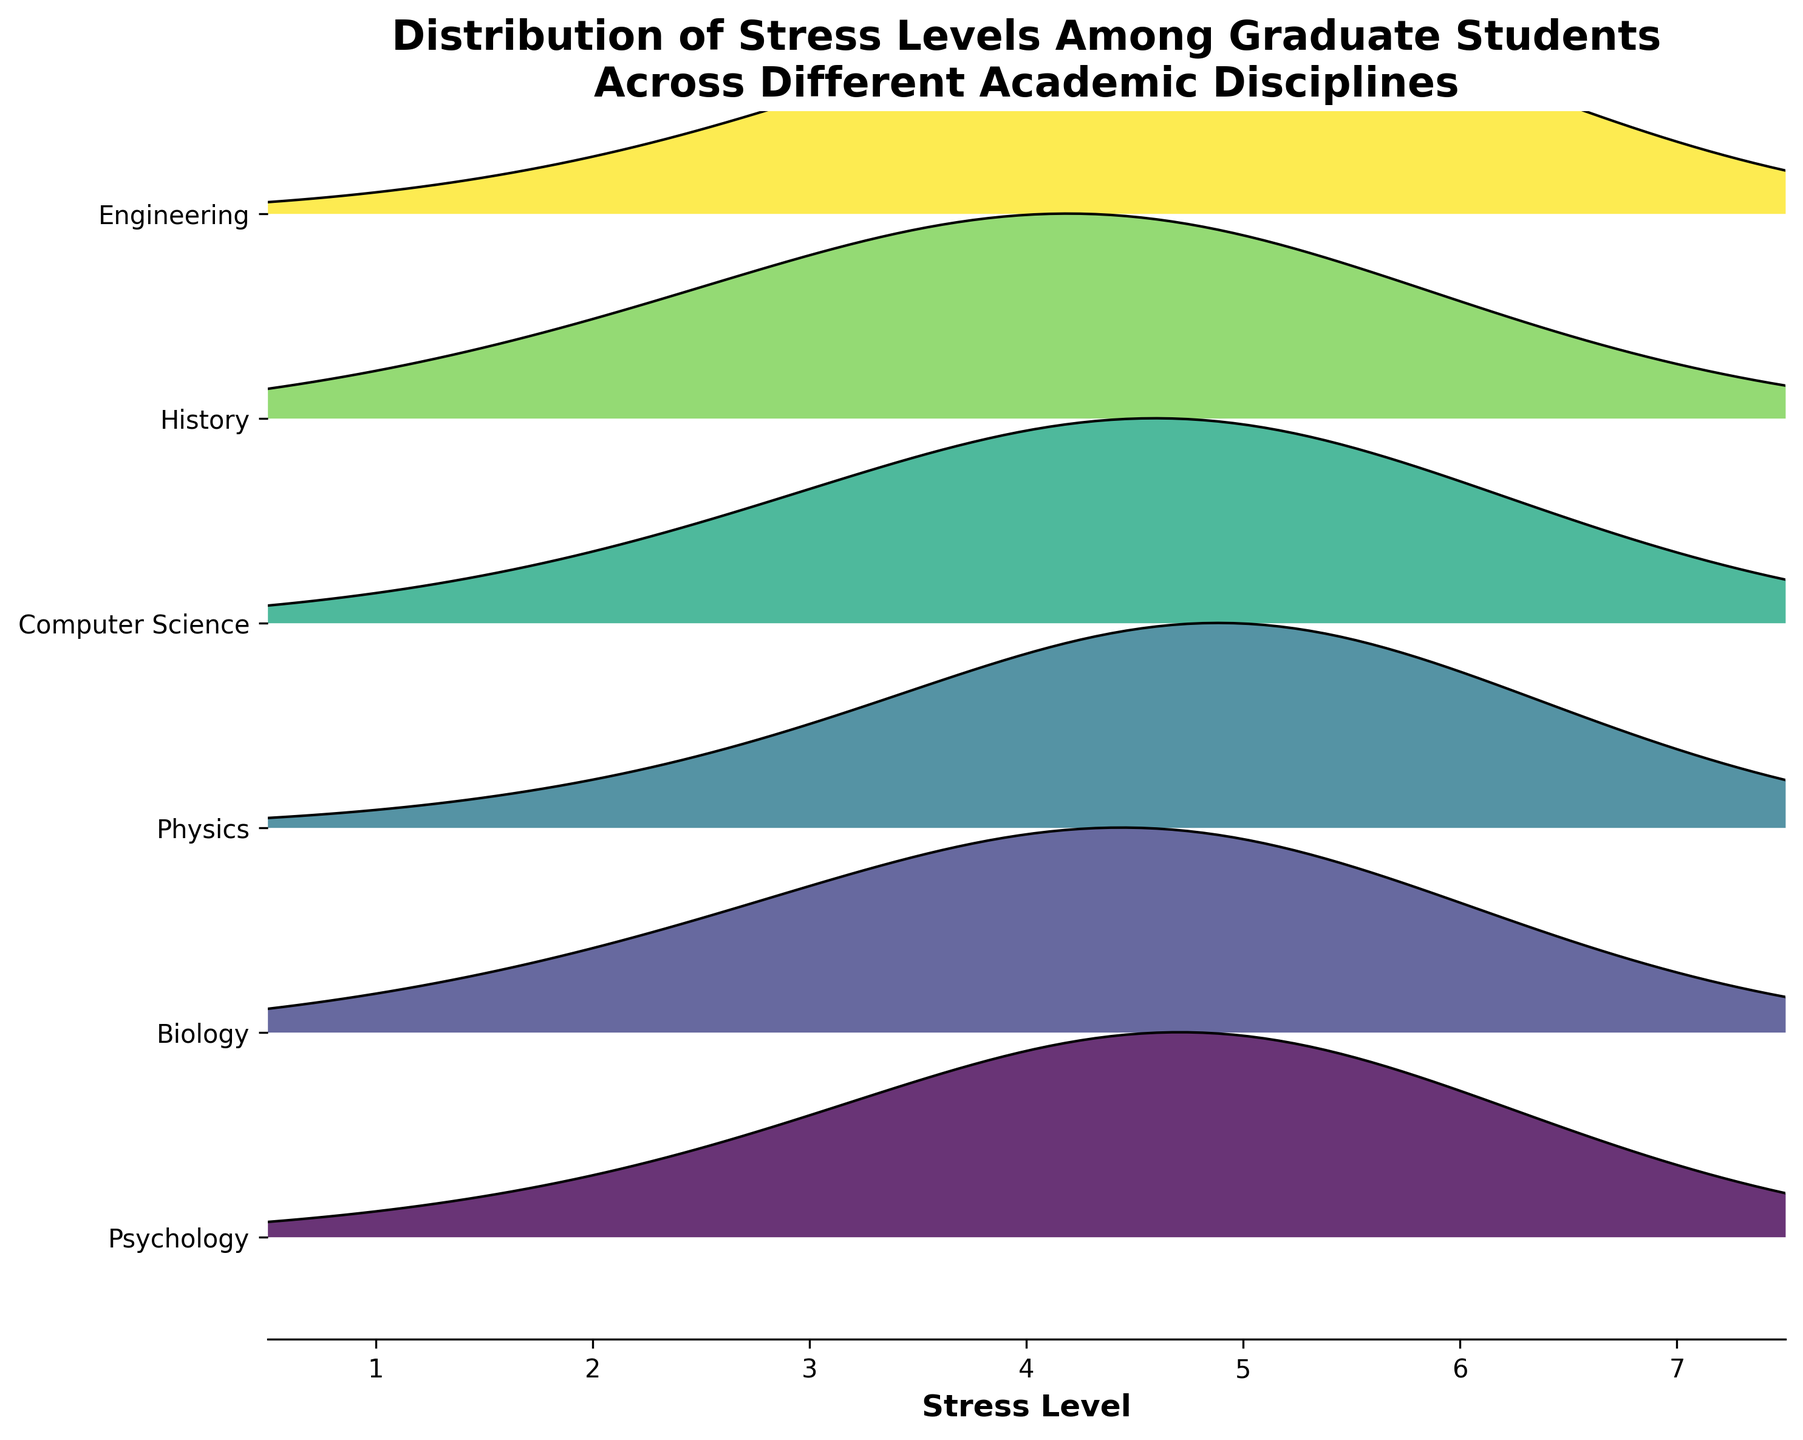What is the title of the figure? The title is usually found at the top of the figure, generally in a larger, bold font for emphasis. It summarizes the content of the plot.
Answer: Distribution of Stress Levels Among Graduate Students Across Different Academic Disciplines Which academic discipline shows the highest peak in stress levels? By examining the height of the peaks in the ridgeline plot, we can determine which discipline has the most pronounced density at any given stress level. Look for the discipline where the peak is closest to the top of the plot.
Answer: Physics Between Psychology and Biology, which discipline has a higher density for stress level 4? To find this, compare the height of the density curve at stress level 4 for both Psychology and Biology. The discipline with the higher peak at this point has the higher density.
Answer: Biology What is the range of stress levels shown in the plot? The x-axis of the plot provides the range of stress levels. Check the minimum and maximum values labeled on the x-axis.
Answer: 1 to 7 Which discipline has the most even distribution of stress levels, meaning no significant peaks? An even distribution would mean the density values change gently and gradually rather than having sharp peaks. Look for the plot line that is relatively flat without pronounced peaks.
Answer: History Are any disciplines showing a bimodal distribution of stress levels? A bimodal distribution would have two distinct peaks in the density curve. Scan the plot for any discipline with two separate high points in its density curve.
Answer: No Do any disciplines have their highest density at a stress level below 4? Determine whether any of the density curves reach their highest point (peak) in the areas representing stress levels 1, 2, or 3. Check the curves accordingly.
Answer: No Which discipline appears to have the least variance in stress levels? The discipline with the least variance will have a density curve that's narrow and concentrated around its peak. Look for the tightest, most focused density distribution.
Answer: Physics Compare the density of stress levels of 5 and 6 in Engineering and Computer Science. Which discipline has higher densities at these levels? Check the height of the density curves at stress levels 5 and 6 for both Engineering and Computer Science. Compare these heights to determine which discipline has the higher densities at these levels.
Answer: Engineering What do the colors represent in the plot? The colors distinguish the different academic disciplines from each other. Each discipline is assigned a specific color for visual differentiation. Identify this by observing how the colors group the curves.
Answer: Different academic disciplines 